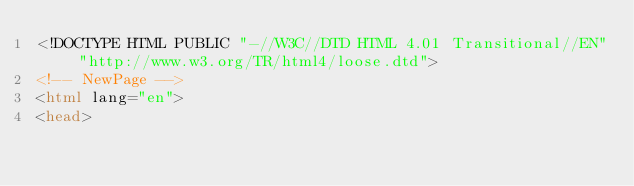<code> <loc_0><loc_0><loc_500><loc_500><_HTML_><!DOCTYPE HTML PUBLIC "-//W3C//DTD HTML 4.01 Transitional//EN" "http://www.w3.org/TR/html4/loose.dtd">
<!-- NewPage -->
<html lang="en">
<head></code> 